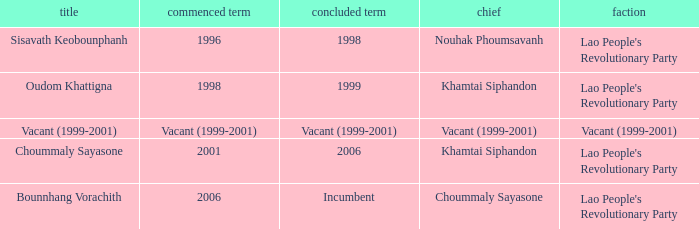What is Left Office, when Party is Vacant (1999-2001)? Vacant (1999-2001). 